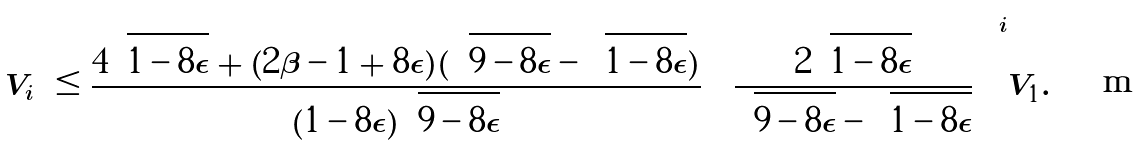<formula> <loc_0><loc_0><loc_500><loc_500>| V _ { i } | & \leq \frac { 4 \sqrt { 1 - 8 \epsilon } + ( 2 \beta - 1 + 8 \epsilon ) ( \sqrt { 9 - 8 \epsilon } - \sqrt { 1 - 8 \epsilon } ) } { ( 1 - 8 \epsilon ) \sqrt { 9 - 8 \epsilon } } \left ( \frac { 2 \sqrt { 1 - 8 \epsilon } } { \sqrt { 9 - 8 \epsilon } - \sqrt { 1 - 8 \epsilon } } \right ) ^ { i } | V _ { 1 } | .</formula> 